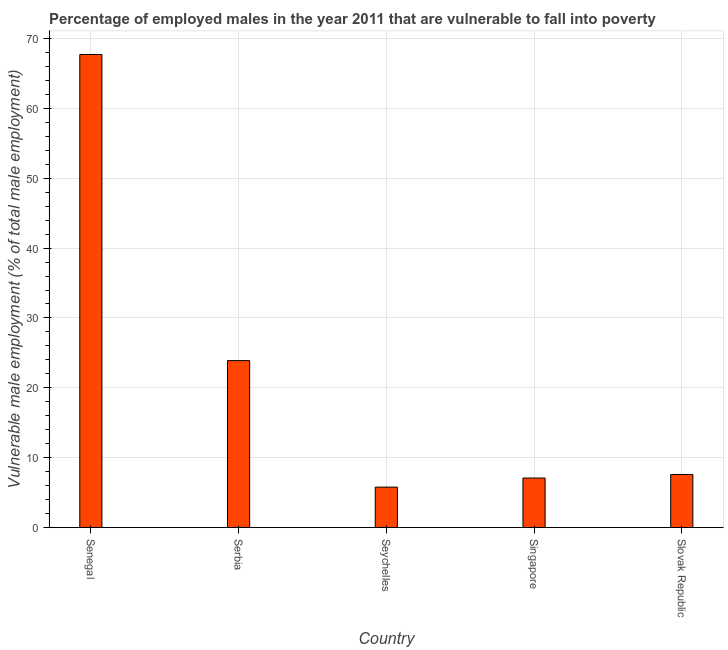What is the title of the graph?
Offer a very short reply. Percentage of employed males in the year 2011 that are vulnerable to fall into poverty. What is the label or title of the X-axis?
Give a very brief answer. Country. What is the label or title of the Y-axis?
Offer a very short reply. Vulnerable male employment (% of total male employment). What is the percentage of employed males who are vulnerable to fall into poverty in Serbia?
Offer a terse response. 23.9. Across all countries, what is the maximum percentage of employed males who are vulnerable to fall into poverty?
Offer a very short reply. 67.7. Across all countries, what is the minimum percentage of employed males who are vulnerable to fall into poverty?
Your answer should be very brief. 5.8. In which country was the percentage of employed males who are vulnerable to fall into poverty maximum?
Offer a terse response. Senegal. In which country was the percentage of employed males who are vulnerable to fall into poverty minimum?
Keep it short and to the point. Seychelles. What is the sum of the percentage of employed males who are vulnerable to fall into poverty?
Your answer should be very brief. 112.1. What is the difference between the percentage of employed males who are vulnerable to fall into poverty in Singapore and Slovak Republic?
Keep it short and to the point. -0.5. What is the average percentage of employed males who are vulnerable to fall into poverty per country?
Make the answer very short. 22.42. What is the median percentage of employed males who are vulnerable to fall into poverty?
Your response must be concise. 7.6. What is the ratio of the percentage of employed males who are vulnerable to fall into poverty in Seychelles to that in Slovak Republic?
Your response must be concise. 0.76. What is the difference between the highest and the second highest percentage of employed males who are vulnerable to fall into poverty?
Offer a terse response. 43.8. Is the sum of the percentage of employed males who are vulnerable to fall into poverty in Serbia and Seychelles greater than the maximum percentage of employed males who are vulnerable to fall into poverty across all countries?
Provide a short and direct response. No. What is the difference between the highest and the lowest percentage of employed males who are vulnerable to fall into poverty?
Your answer should be very brief. 61.9. In how many countries, is the percentage of employed males who are vulnerable to fall into poverty greater than the average percentage of employed males who are vulnerable to fall into poverty taken over all countries?
Provide a short and direct response. 2. How many bars are there?
Your answer should be compact. 5. What is the Vulnerable male employment (% of total male employment) in Senegal?
Give a very brief answer. 67.7. What is the Vulnerable male employment (% of total male employment) of Serbia?
Offer a terse response. 23.9. What is the Vulnerable male employment (% of total male employment) of Seychelles?
Your answer should be compact. 5.8. What is the Vulnerable male employment (% of total male employment) in Singapore?
Offer a very short reply. 7.1. What is the Vulnerable male employment (% of total male employment) in Slovak Republic?
Your response must be concise. 7.6. What is the difference between the Vulnerable male employment (% of total male employment) in Senegal and Serbia?
Keep it short and to the point. 43.8. What is the difference between the Vulnerable male employment (% of total male employment) in Senegal and Seychelles?
Make the answer very short. 61.9. What is the difference between the Vulnerable male employment (% of total male employment) in Senegal and Singapore?
Your response must be concise. 60.6. What is the difference between the Vulnerable male employment (% of total male employment) in Senegal and Slovak Republic?
Offer a terse response. 60.1. What is the difference between the Vulnerable male employment (% of total male employment) in Serbia and Seychelles?
Offer a very short reply. 18.1. What is the difference between the Vulnerable male employment (% of total male employment) in Serbia and Slovak Republic?
Provide a short and direct response. 16.3. What is the ratio of the Vulnerable male employment (% of total male employment) in Senegal to that in Serbia?
Provide a succinct answer. 2.83. What is the ratio of the Vulnerable male employment (% of total male employment) in Senegal to that in Seychelles?
Your response must be concise. 11.67. What is the ratio of the Vulnerable male employment (% of total male employment) in Senegal to that in Singapore?
Offer a very short reply. 9.54. What is the ratio of the Vulnerable male employment (% of total male employment) in Senegal to that in Slovak Republic?
Your answer should be compact. 8.91. What is the ratio of the Vulnerable male employment (% of total male employment) in Serbia to that in Seychelles?
Offer a terse response. 4.12. What is the ratio of the Vulnerable male employment (% of total male employment) in Serbia to that in Singapore?
Provide a short and direct response. 3.37. What is the ratio of the Vulnerable male employment (% of total male employment) in Serbia to that in Slovak Republic?
Ensure brevity in your answer.  3.15. What is the ratio of the Vulnerable male employment (% of total male employment) in Seychelles to that in Singapore?
Offer a terse response. 0.82. What is the ratio of the Vulnerable male employment (% of total male employment) in Seychelles to that in Slovak Republic?
Provide a short and direct response. 0.76. What is the ratio of the Vulnerable male employment (% of total male employment) in Singapore to that in Slovak Republic?
Your answer should be very brief. 0.93. 